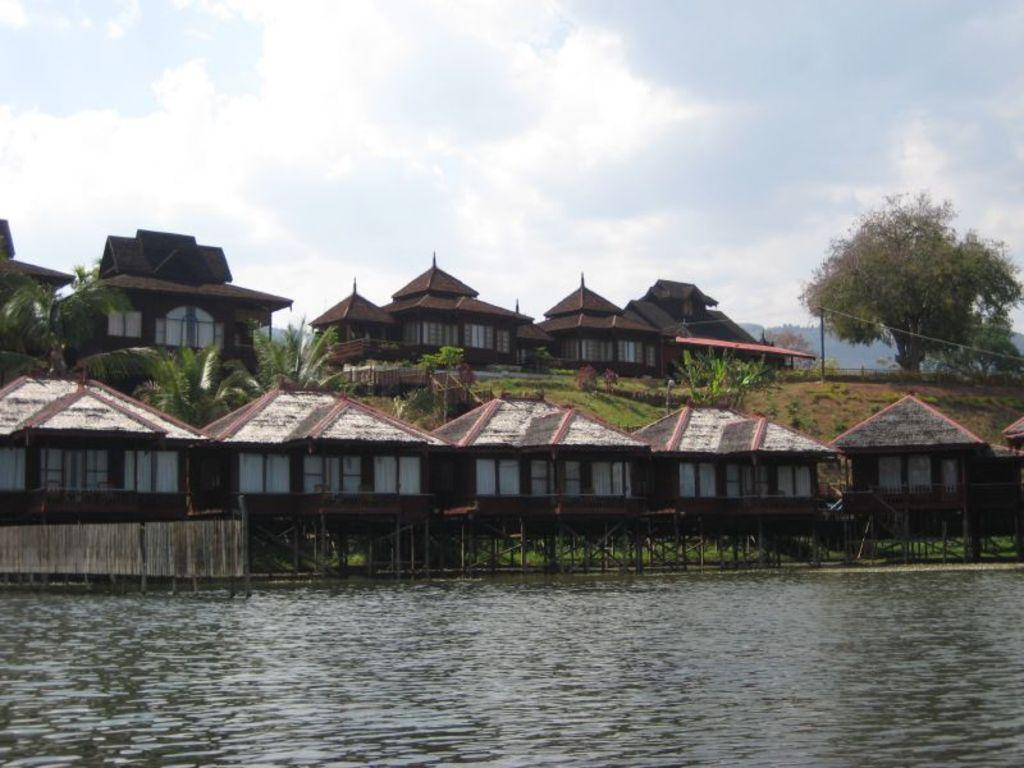What is the primary element visible in the image? There is water in the image. What type of structures can be seen in the background? There are cottages with roofs in the background. What other natural elements are present in the background? There are trees in the background. What can be seen in the sky in the image? There are clouds in the sky. How many thumbs can be seen in the image? There are no thumbs visible in the image. What type of farm animals can be seen in the image? There are no farm animals present in the image. 